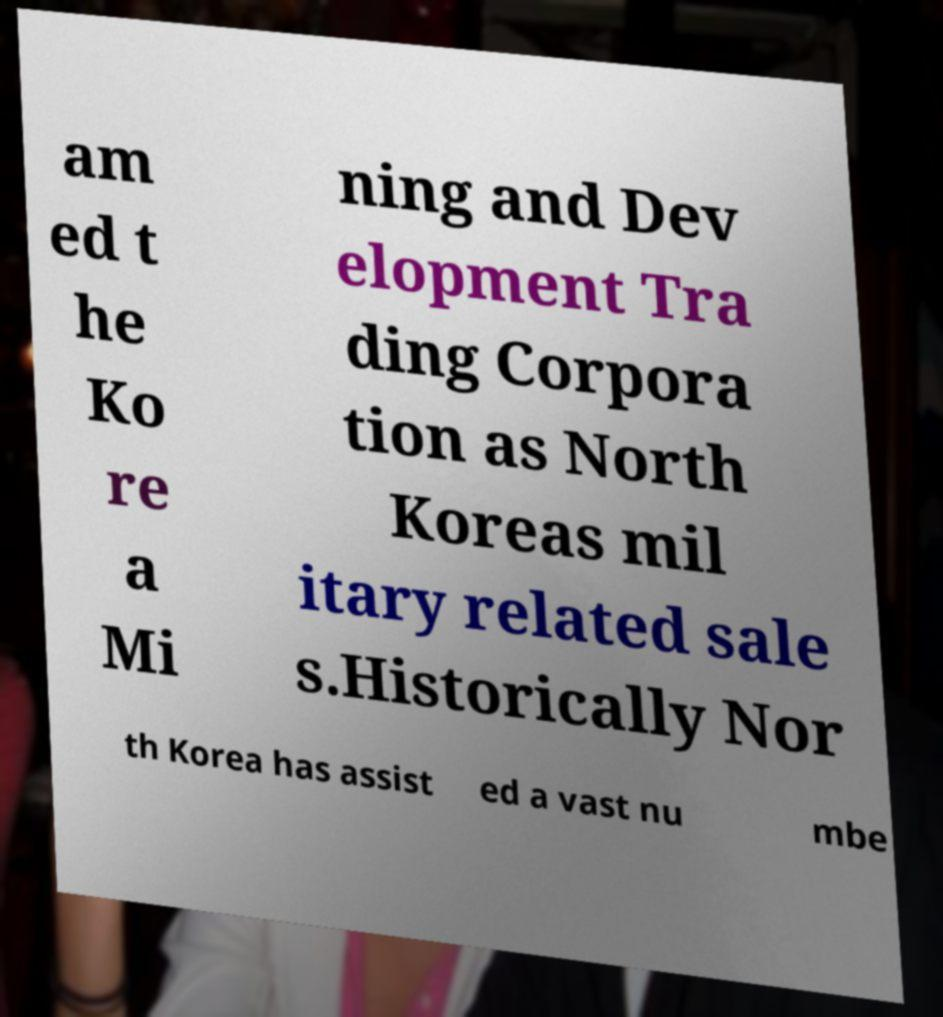There's text embedded in this image that I need extracted. Can you transcribe it verbatim? am ed t he Ko re a Mi ning and Dev elopment Tra ding Corpora tion as North Koreas mil itary related sale s.Historically Nor th Korea has assist ed a vast nu mbe 